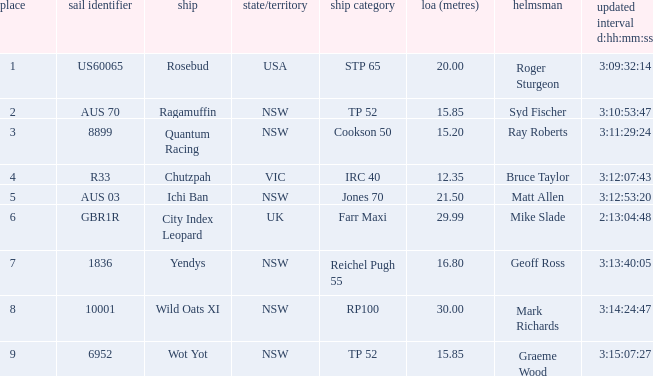What are all sail numbers for the yacht Yendys? 1836.0. 